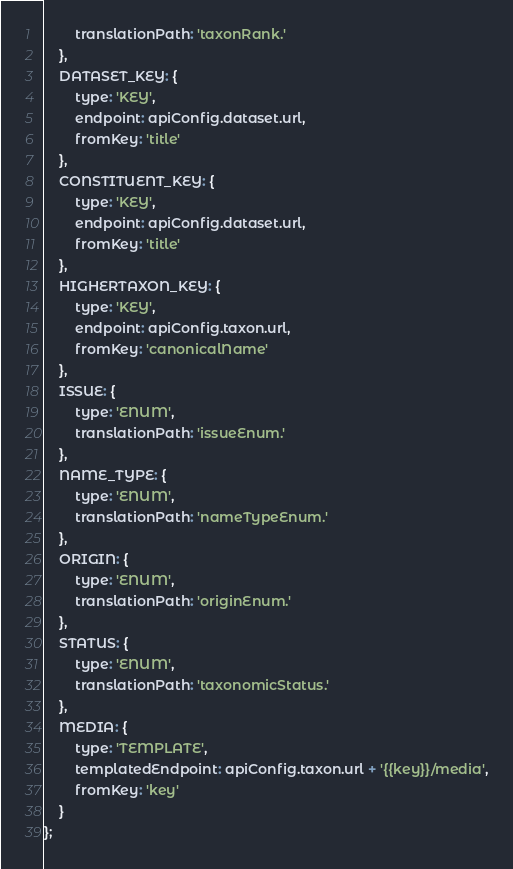Convert code to text. <code><loc_0><loc_0><loc_500><loc_500><_JavaScript_>        translationPath: 'taxonRank.'
    },
    DATASET_KEY: {
        type: 'KEY',
        endpoint: apiConfig.dataset.url,
        fromKey: 'title'
    },
    CONSTITUENT_KEY: {
        type: 'KEY',
        endpoint: apiConfig.dataset.url,
        fromKey: 'title'
    },
    HIGHERTAXON_KEY: {
        type: 'KEY',
        endpoint: apiConfig.taxon.url,
        fromKey: 'canonicalName'
    },
    ISSUE: {
        type: 'ENUM',
        translationPath: 'issueEnum.'
    },
    NAME_TYPE: {
        type: 'ENUM',
        translationPath: 'nameTypeEnum.'
    },
    ORIGIN: {
        type: 'ENUM',
        translationPath: 'originEnum.'
    },
    STATUS: {
        type: 'ENUM',
        translationPath: 'taxonomicStatus.'
    },
    MEDIA: {
        type: 'TEMPLATE',
        templatedEndpoint: apiConfig.taxon.url + '{{key}}/media',
        fromKey: 'key'
    }
};
</code> 